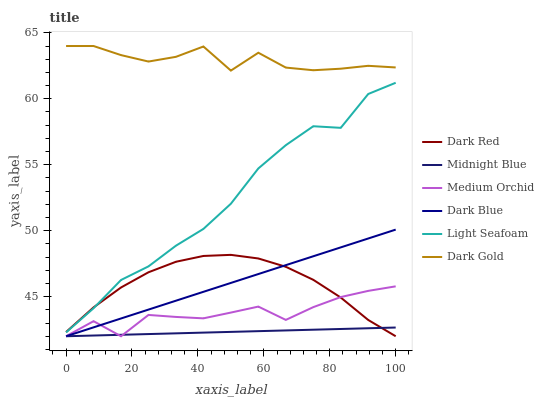Does Dark Red have the minimum area under the curve?
Answer yes or no. No. Does Dark Red have the maximum area under the curve?
Answer yes or no. No. Is Dark Red the smoothest?
Answer yes or no. No. Is Dark Red the roughest?
Answer yes or no. No. Does Dark Gold have the lowest value?
Answer yes or no. No. Does Dark Red have the highest value?
Answer yes or no. No. Is Dark Blue less than Light Seafoam?
Answer yes or no. Yes. Is Dark Gold greater than Light Seafoam?
Answer yes or no. Yes. Does Dark Blue intersect Light Seafoam?
Answer yes or no. No. 